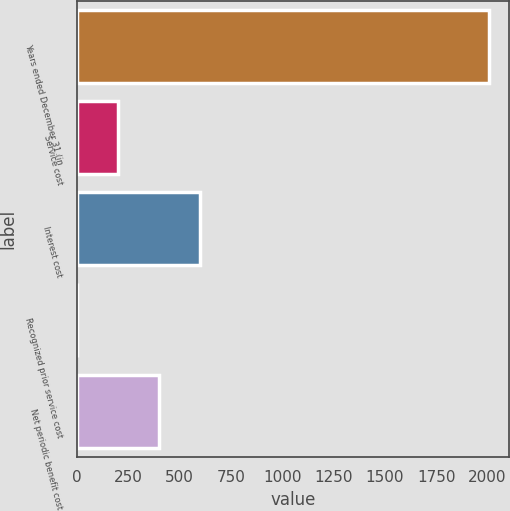Convert chart to OTSL. <chart><loc_0><loc_0><loc_500><loc_500><bar_chart><fcel>Years ended December 31 (in<fcel>Service cost<fcel>Interest cost<fcel>Recognized prior service cost<fcel>Net periodic benefit cost<nl><fcel>2005<fcel>200.59<fcel>601.57<fcel>0.1<fcel>401.08<nl></chart> 